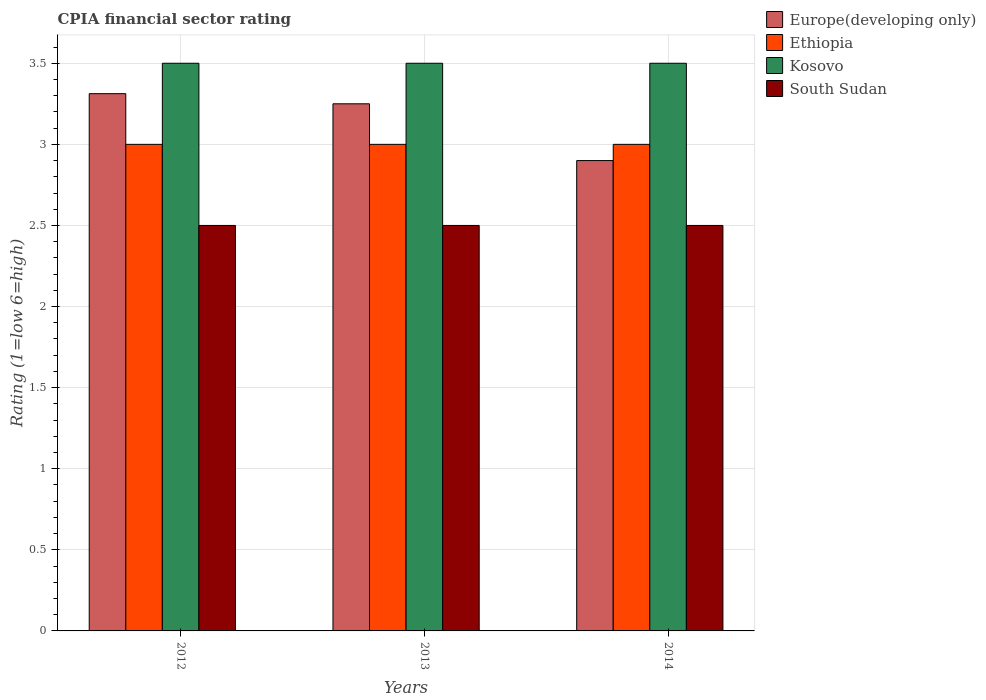How many groups of bars are there?
Your response must be concise. 3. Are the number of bars per tick equal to the number of legend labels?
Provide a succinct answer. Yes. Are the number of bars on each tick of the X-axis equal?
Offer a very short reply. Yes. How many bars are there on the 2nd tick from the right?
Offer a terse response. 4. What is the label of the 1st group of bars from the left?
Make the answer very short. 2012. What is the CPIA rating in Ethiopia in 2013?
Give a very brief answer. 3. Across all years, what is the maximum CPIA rating in Kosovo?
Keep it short and to the point. 3.5. Across all years, what is the minimum CPIA rating in Ethiopia?
Your answer should be very brief. 3. What is the total CPIA rating in Europe(developing only) in the graph?
Provide a succinct answer. 9.46. What is the difference between the CPIA rating in Europe(developing only) in 2012 and that in 2013?
Make the answer very short. 0.06. What is the average CPIA rating in Kosovo per year?
Provide a succinct answer. 3.5. In the year 2013, what is the difference between the CPIA rating in Europe(developing only) and CPIA rating in South Sudan?
Offer a terse response. 0.75. In how many years, is the CPIA rating in Europe(developing only) greater than 0.2?
Your response must be concise. 3. What is the ratio of the CPIA rating in South Sudan in 2012 to that in 2013?
Make the answer very short. 1. Is the CPIA rating in Ethiopia in 2012 less than that in 2014?
Provide a succinct answer. No. What is the difference between the highest and the second highest CPIA rating in Europe(developing only)?
Ensure brevity in your answer.  0.06. What is the difference between the highest and the lowest CPIA rating in Europe(developing only)?
Offer a very short reply. 0.41. In how many years, is the CPIA rating in Europe(developing only) greater than the average CPIA rating in Europe(developing only) taken over all years?
Offer a very short reply. 2. What does the 1st bar from the left in 2012 represents?
Provide a short and direct response. Europe(developing only). What does the 1st bar from the right in 2013 represents?
Offer a very short reply. South Sudan. Is it the case that in every year, the sum of the CPIA rating in Europe(developing only) and CPIA rating in Kosovo is greater than the CPIA rating in South Sudan?
Offer a very short reply. Yes. How many bars are there?
Ensure brevity in your answer.  12. Are all the bars in the graph horizontal?
Offer a very short reply. No. How many years are there in the graph?
Provide a short and direct response. 3. What is the difference between two consecutive major ticks on the Y-axis?
Your answer should be very brief. 0.5. Does the graph contain any zero values?
Make the answer very short. No. Does the graph contain grids?
Offer a terse response. Yes. Where does the legend appear in the graph?
Make the answer very short. Top right. What is the title of the graph?
Ensure brevity in your answer.  CPIA financial sector rating. Does "Malawi" appear as one of the legend labels in the graph?
Your answer should be compact. No. What is the label or title of the X-axis?
Provide a succinct answer. Years. What is the label or title of the Y-axis?
Provide a succinct answer. Rating (1=low 6=high). What is the Rating (1=low 6=high) of Europe(developing only) in 2012?
Ensure brevity in your answer.  3.31. What is the Rating (1=low 6=high) of Ethiopia in 2012?
Your response must be concise. 3. What is the Rating (1=low 6=high) in Kosovo in 2012?
Provide a succinct answer. 3.5. What is the Rating (1=low 6=high) in South Sudan in 2012?
Your response must be concise. 2.5. What is the Rating (1=low 6=high) of Ethiopia in 2013?
Ensure brevity in your answer.  3. What is the Rating (1=low 6=high) of Kosovo in 2013?
Offer a terse response. 3.5. What is the Rating (1=low 6=high) in South Sudan in 2013?
Give a very brief answer. 2.5. What is the Rating (1=low 6=high) of Ethiopia in 2014?
Offer a very short reply. 3. What is the Rating (1=low 6=high) of Kosovo in 2014?
Offer a very short reply. 3.5. Across all years, what is the maximum Rating (1=low 6=high) of Europe(developing only)?
Your response must be concise. 3.31. Across all years, what is the maximum Rating (1=low 6=high) in Ethiopia?
Offer a very short reply. 3. Across all years, what is the maximum Rating (1=low 6=high) in Kosovo?
Offer a very short reply. 3.5. Across all years, what is the maximum Rating (1=low 6=high) of South Sudan?
Offer a terse response. 2.5. Across all years, what is the minimum Rating (1=low 6=high) in Europe(developing only)?
Provide a succinct answer. 2.9. Across all years, what is the minimum Rating (1=low 6=high) in Kosovo?
Offer a terse response. 3.5. What is the total Rating (1=low 6=high) of Europe(developing only) in the graph?
Offer a terse response. 9.46. What is the total Rating (1=low 6=high) of Kosovo in the graph?
Ensure brevity in your answer.  10.5. What is the total Rating (1=low 6=high) of South Sudan in the graph?
Give a very brief answer. 7.5. What is the difference between the Rating (1=low 6=high) of Europe(developing only) in 2012 and that in 2013?
Make the answer very short. 0.06. What is the difference between the Rating (1=low 6=high) in Europe(developing only) in 2012 and that in 2014?
Provide a short and direct response. 0.41. What is the difference between the Rating (1=low 6=high) in Ethiopia in 2012 and that in 2014?
Offer a terse response. 0. What is the difference between the Rating (1=low 6=high) of Ethiopia in 2013 and that in 2014?
Your answer should be compact. 0. What is the difference between the Rating (1=low 6=high) in Europe(developing only) in 2012 and the Rating (1=low 6=high) in Ethiopia in 2013?
Give a very brief answer. 0.31. What is the difference between the Rating (1=low 6=high) of Europe(developing only) in 2012 and the Rating (1=low 6=high) of Kosovo in 2013?
Make the answer very short. -0.19. What is the difference between the Rating (1=low 6=high) of Europe(developing only) in 2012 and the Rating (1=low 6=high) of South Sudan in 2013?
Keep it short and to the point. 0.81. What is the difference between the Rating (1=low 6=high) in Ethiopia in 2012 and the Rating (1=low 6=high) in Kosovo in 2013?
Offer a very short reply. -0.5. What is the difference between the Rating (1=low 6=high) in Europe(developing only) in 2012 and the Rating (1=low 6=high) in Ethiopia in 2014?
Your answer should be compact. 0.31. What is the difference between the Rating (1=low 6=high) of Europe(developing only) in 2012 and the Rating (1=low 6=high) of Kosovo in 2014?
Provide a succinct answer. -0.19. What is the difference between the Rating (1=low 6=high) in Europe(developing only) in 2012 and the Rating (1=low 6=high) in South Sudan in 2014?
Give a very brief answer. 0.81. What is the difference between the Rating (1=low 6=high) of Ethiopia in 2012 and the Rating (1=low 6=high) of Kosovo in 2014?
Offer a very short reply. -0.5. What is the difference between the Rating (1=low 6=high) of Ethiopia in 2012 and the Rating (1=low 6=high) of South Sudan in 2014?
Provide a short and direct response. 0.5. What is the difference between the Rating (1=low 6=high) in Europe(developing only) in 2013 and the Rating (1=low 6=high) in Ethiopia in 2014?
Offer a terse response. 0.25. What is the difference between the Rating (1=low 6=high) of Europe(developing only) in 2013 and the Rating (1=low 6=high) of South Sudan in 2014?
Your answer should be very brief. 0.75. What is the difference between the Rating (1=low 6=high) of Ethiopia in 2013 and the Rating (1=low 6=high) of Kosovo in 2014?
Your answer should be compact. -0.5. What is the difference between the Rating (1=low 6=high) of Kosovo in 2013 and the Rating (1=low 6=high) of South Sudan in 2014?
Provide a short and direct response. 1. What is the average Rating (1=low 6=high) of Europe(developing only) per year?
Your answer should be compact. 3.15. What is the average Rating (1=low 6=high) of Ethiopia per year?
Offer a very short reply. 3. What is the average Rating (1=low 6=high) in Kosovo per year?
Ensure brevity in your answer.  3.5. In the year 2012, what is the difference between the Rating (1=low 6=high) in Europe(developing only) and Rating (1=low 6=high) in Ethiopia?
Offer a very short reply. 0.31. In the year 2012, what is the difference between the Rating (1=low 6=high) in Europe(developing only) and Rating (1=low 6=high) in Kosovo?
Your answer should be very brief. -0.19. In the year 2012, what is the difference between the Rating (1=low 6=high) in Europe(developing only) and Rating (1=low 6=high) in South Sudan?
Offer a terse response. 0.81. In the year 2013, what is the difference between the Rating (1=low 6=high) of Ethiopia and Rating (1=low 6=high) of Kosovo?
Your answer should be very brief. -0.5. In the year 2014, what is the difference between the Rating (1=low 6=high) of Europe(developing only) and Rating (1=low 6=high) of Ethiopia?
Ensure brevity in your answer.  -0.1. In the year 2014, what is the difference between the Rating (1=low 6=high) of Europe(developing only) and Rating (1=low 6=high) of South Sudan?
Make the answer very short. 0.4. In the year 2014, what is the difference between the Rating (1=low 6=high) of Ethiopia and Rating (1=low 6=high) of South Sudan?
Keep it short and to the point. 0.5. What is the ratio of the Rating (1=low 6=high) in Europe(developing only) in 2012 to that in 2013?
Offer a very short reply. 1.02. What is the ratio of the Rating (1=low 6=high) in Kosovo in 2012 to that in 2013?
Offer a terse response. 1. What is the ratio of the Rating (1=low 6=high) of South Sudan in 2012 to that in 2013?
Offer a very short reply. 1. What is the ratio of the Rating (1=low 6=high) of Europe(developing only) in 2012 to that in 2014?
Offer a terse response. 1.14. What is the ratio of the Rating (1=low 6=high) of Kosovo in 2012 to that in 2014?
Keep it short and to the point. 1. What is the ratio of the Rating (1=low 6=high) of Europe(developing only) in 2013 to that in 2014?
Ensure brevity in your answer.  1.12. What is the ratio of the Rating (1=low 6=high) of Kosovo in 2013 to that in 2014?
Your answer should be compact. 1. What is the difference between the highest and the second highest Rating (1=low 6=high) of Europe(developing only)?
Give a very brief answer. 0.06. What is the difference between the highest and the second highest Rating (1=low 6=high) of Ethiopia?
Your answer should be compact. 0. What is the difference between the highest and the second highest Rating (1=low 6=high) in Kosovo?
Your answer should be compact. 0. What is the difference between the highest and the lowest Rating (1=low 6=high) of Europe(developing only)?
Give a very brief answer. 0.41. What is the difference between the highest and the lowest Rating (1=low 6=high) in Kosovo?
Ensure brevity in your answer.  0. What is the difference between the highest and the lowest Rating (1=low 6=high) in South Sudan?
Provide a short and direct response. 0. 